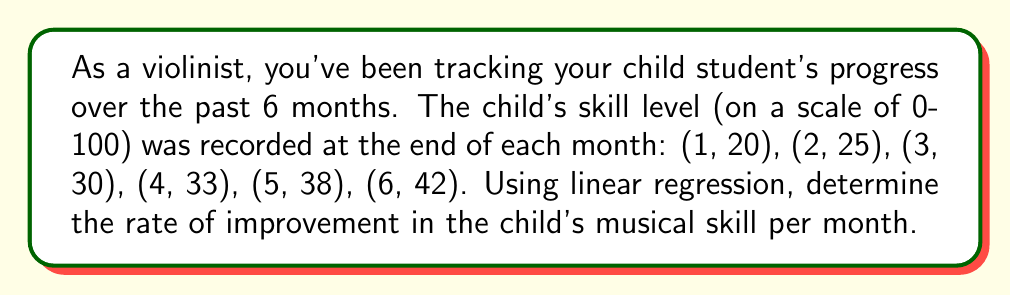Can you answer this question? To find the rate of improvement using linear regression, we need to calculate the slope of the best-fit line. We'll use the formula:

$$ m = \frac{n\sum xy - \sum x \sum y}{n\sum x^2 - (\sum x)^2} $$

Where $m$ is the slope, $n$ is the number of data points, $x$ represents the months, and $y$ represents the skill levels.

Step 1: Calculate the sums needed for the formula:
$n = 6$
$\sum x = 1 + 2 + 3 + 4 + 5 + 6 = 21$
$\sum y = 20 + 25 + 30 + 33 + 38 + 42 = 188$
$\sum xy = 1(20) + 2(25) + 3(30) + 4(33) + 5(38) + 6(42) = 731$
$\sum x^2 = 1^2 + 2^2 + 3^2 + 4^2 + 5^2 + 6^2 = 91$

Step 2: Plug these values into the slope formula:

$$ m = \frac{6(731) - 21(188)}{6(91) - 21^2} $$

Step 3: Simplify:

$$ m = \frac{4386 - 3948}{546 - 441} = \frac{438}{105} $$

Step 4: Calculate the final result:

$$ m = 4.1714... $$

This slope represents the rate of improvement in skill level per month.
Answer: $4.17$ skill points per month 